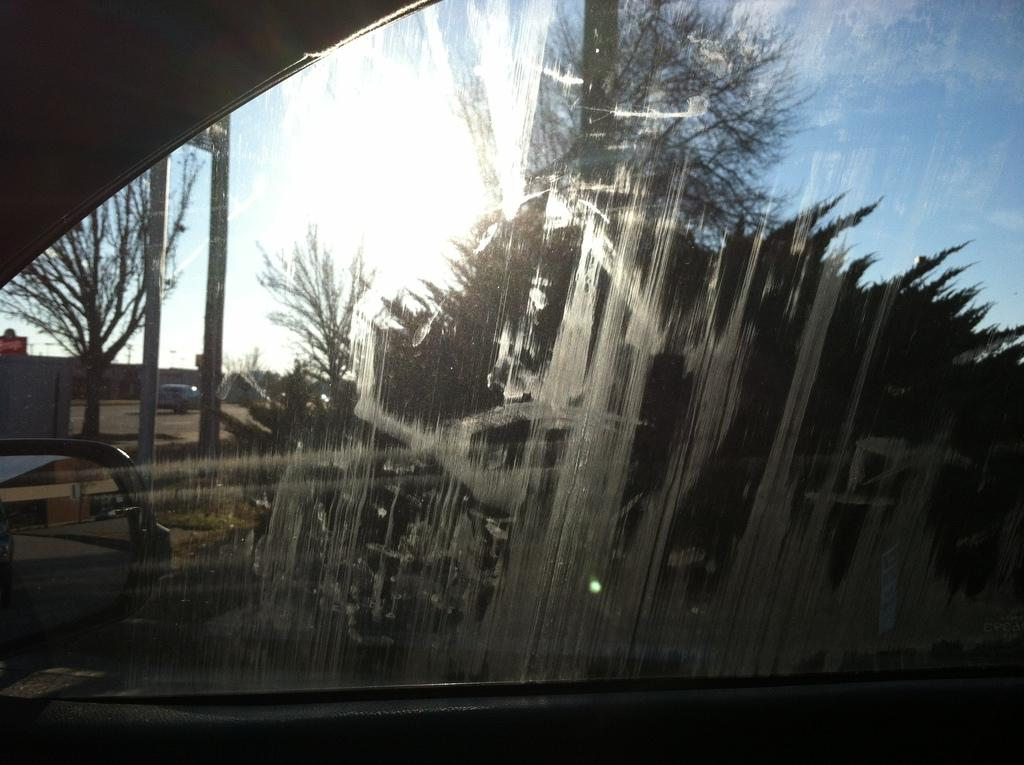What is the main subject in the center of the image? There is a car in the center of the image. What is the purpose of the glass window in the image? The glass window allows the sky, trees, buildings, poles, and one vehicle to be visible through it. Can you describe the view through the glass window? The sky, trees, buildings, poles, and one vehicle are visible through the glass window. Are there any toys visible on the island in the image? There is no island present in the image, and therefore no toys can be seen on it. What type of chalk can be seen being used in the image? There is no chalk or any indication of writing or drawing in the image. 